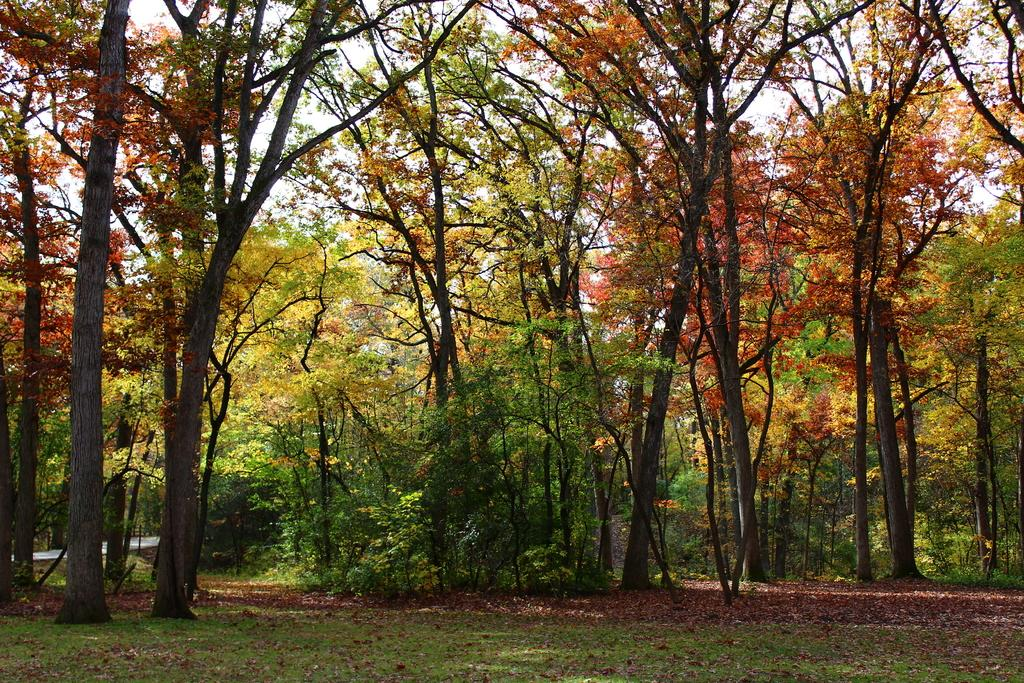What type of vegetation can be seen in the image? There are trees and grass in the image. What else can be found on the ground in the image? Dried leaves are present in the image. What part of the natural environment is visible in the image? Some part of the sky is visible in the image. What is the purpose of the structure in the image? There is no structure present in the image; it features trees, grass, dried leaves, and a portion of the sky. 